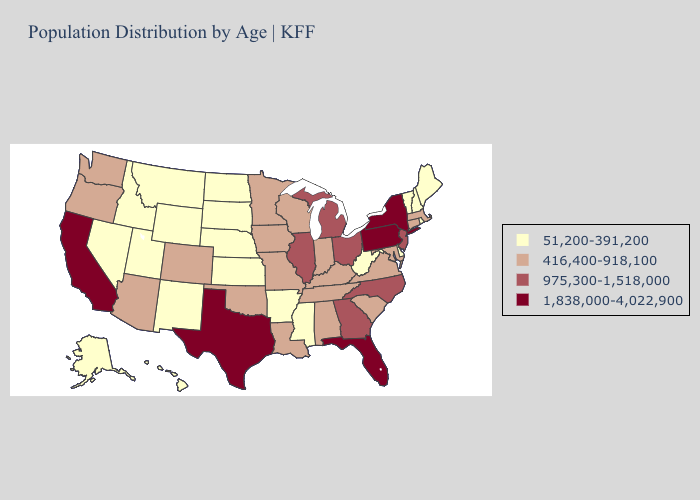Does New Jersey have the lowest value in the Northeast?
Concise answer only. No. What is the value of Nebraska?
Answer briefly. 51,200-391,200. Does Maryland have the highest value in the USA?
Write a very short answer. No. Among the states that border Oklahoma , which have the highest value?
Give a very brief answer. Texas. Among the states that border Arkansas , does Tennessee have the lowest value?
Give a very brief answer. No. Among the states that border Texas , does Arkansas have the lowest value?
Write a very short answer. Yes. How many symbols are there in the legend?
Quick response, please. 4. Name the states that have a value in the range 51,200-391,200?
Concise answer only. Alaska, Arkansas, Delaware, Hawaii, Idaho, Kansas, Maine, Mississippi, Montana, Nebraska, Nevada, New Hampshire, New Mexico, North Dakota, Rhode Island, South Dakota, Utah, Vermont, West Virginia, Wyoming. Name the states that have a value in the range 975,300-1,518,000?
Short answer required. Georgia, Illinois, Michigan, New Jersey, North Carolina, Ohio. Name the states that have a value in the range 51,200-391,200?
Concise answer only. Alaska, Arkansas, Delaware, Hawaii, Idaho, Kansas, Maine, Mississippi, Montana, Nebraska, Nevada, New Hampshire, New Mexico, North Dakota, Rhode Island, South Dakota, Utah, Vermont, West Virginia, Wyoming. What is the value of Massachusetts?
Write a very short answer. 416,400-918,100. Which states hav the highest value in the West?
Quick response, please. California. Is the legend a continuous bar?
Short answer required. No. 